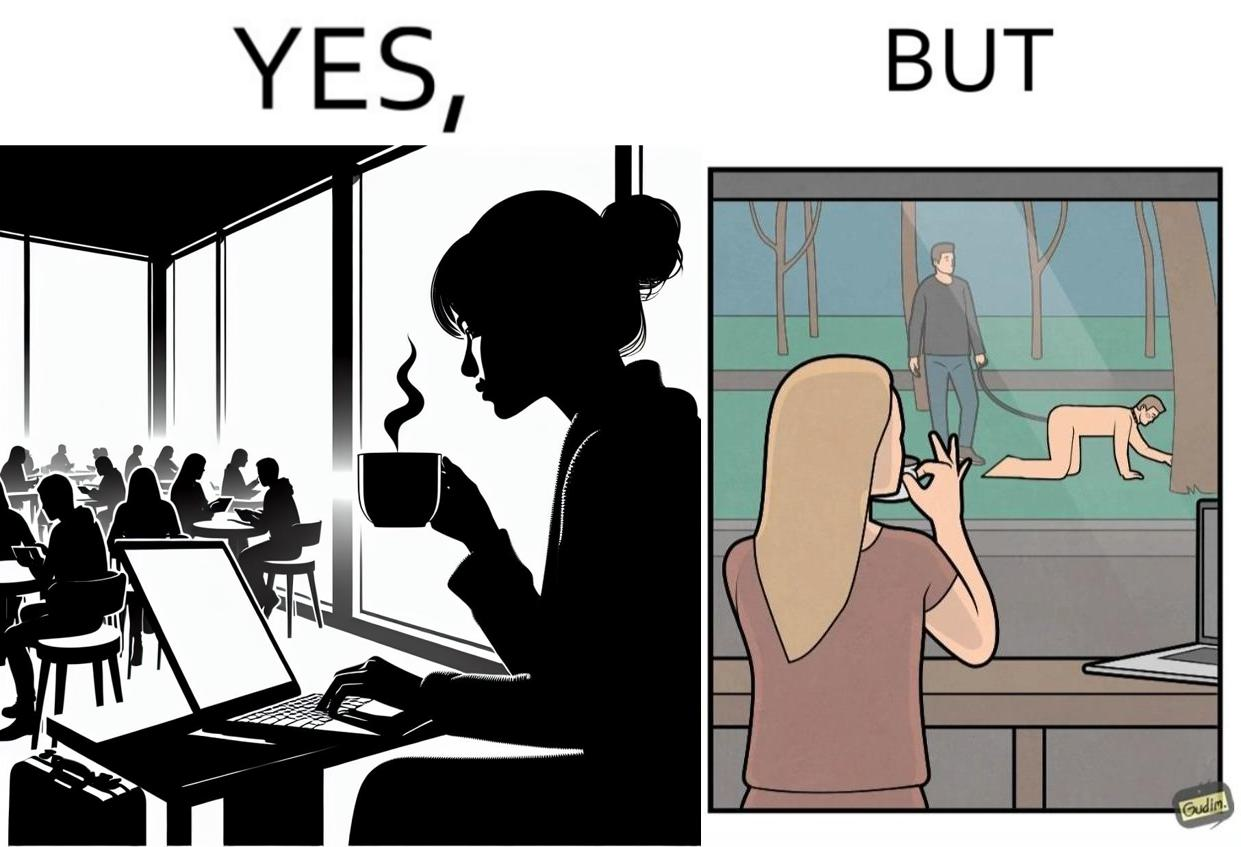What is the satirical meaning behind this image? The image is ironic, because in the first image a woman is seen enjoying her coffee, while watching the injustice happening outside without even having a single thought on the injustice outside and taking some actions or raising some concerns over it 